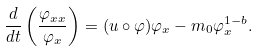<formula> <loc_0><loc_0><loc_500><loc_500>\frac { d } { d t } \left ( \frac { \varphi _ { x x } } { \varphi _ { x } } \right ) = ( u \circ \varphi ) \varphi _ { x } - m _ { 0 } \varphi _ { x } ^ { 1 - b } .</formula> 